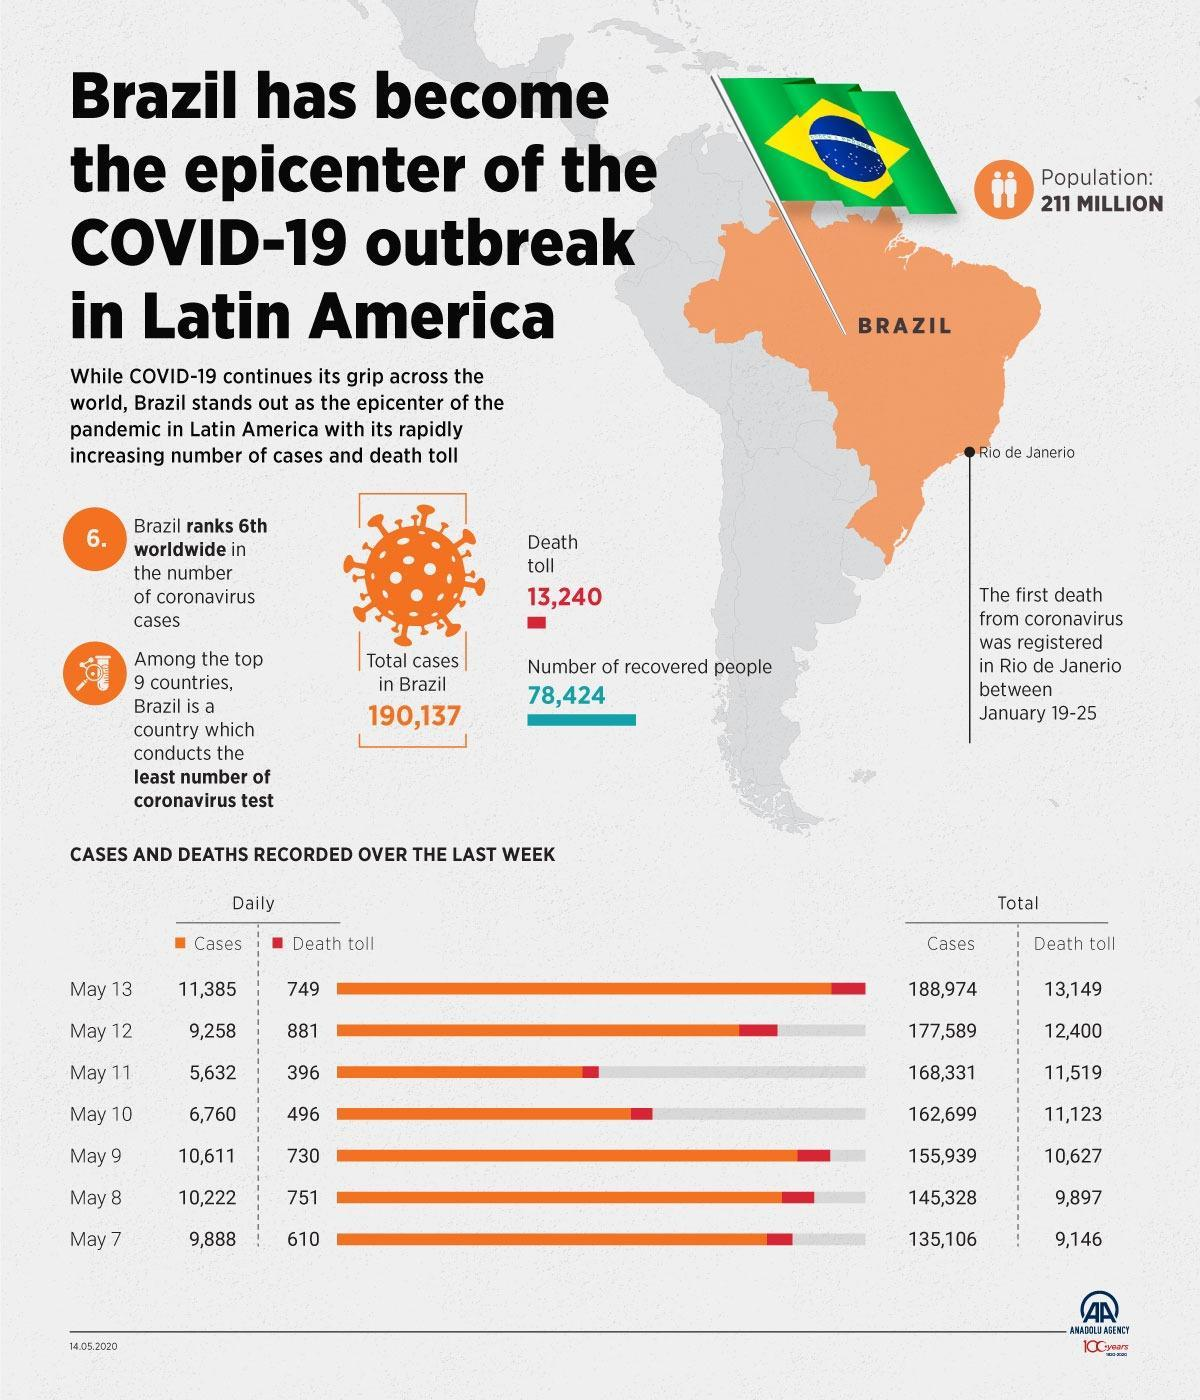What have been the total cases in Brazil
Answer the question with a short phrase. 190,137 WHat has been the total number of deaths on 10th and 11th May 892 Where did the first coronavirus death occur in Brazil Rio de Janerio How many deaths from May 12 to May 13 (both days included) 1630 Brazil is ranked among how many countries for conducting least number of tests 9 What has been the increase in cases from 7th May to 10th May 27593 